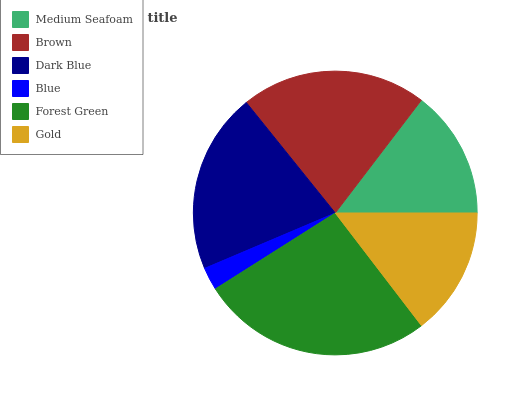Is Blue the minimum?
Answer yes or no. Yes. Is Forest Green the maximum?
Answer yes or no. Yes. Is Brown the minimum?
Answer yes or no. No. Is Brown the maximum?
Answer yes or no. No. Is Brown greater than Medium Seafoam?
Answer yes or no. Yes. Is Medium Seafoam less than Brown?
Answer yes or no. Yes. Is Medium Seafoam greater than Brown?
Answer yes or no. No. Is Brown less than Medium Seafoam?
Answer yes or no. No. Is Dark Blue the high median?
Answer yes or no. Yes. Is Medium Seafoam the low median?
Answer yes or no. Yes. Is Blue the high median?
Answer yes or no. No. Is Blue the low median?
Answer yes or no. No. 